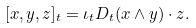Convert formula to latex. <formula><loc_0><loc_0><loc_500><loc_500>[ x , y , z ] _ { t } = \iota _ { t } D _ { t } ( x \wedge y ) \cdot z .</formula> 